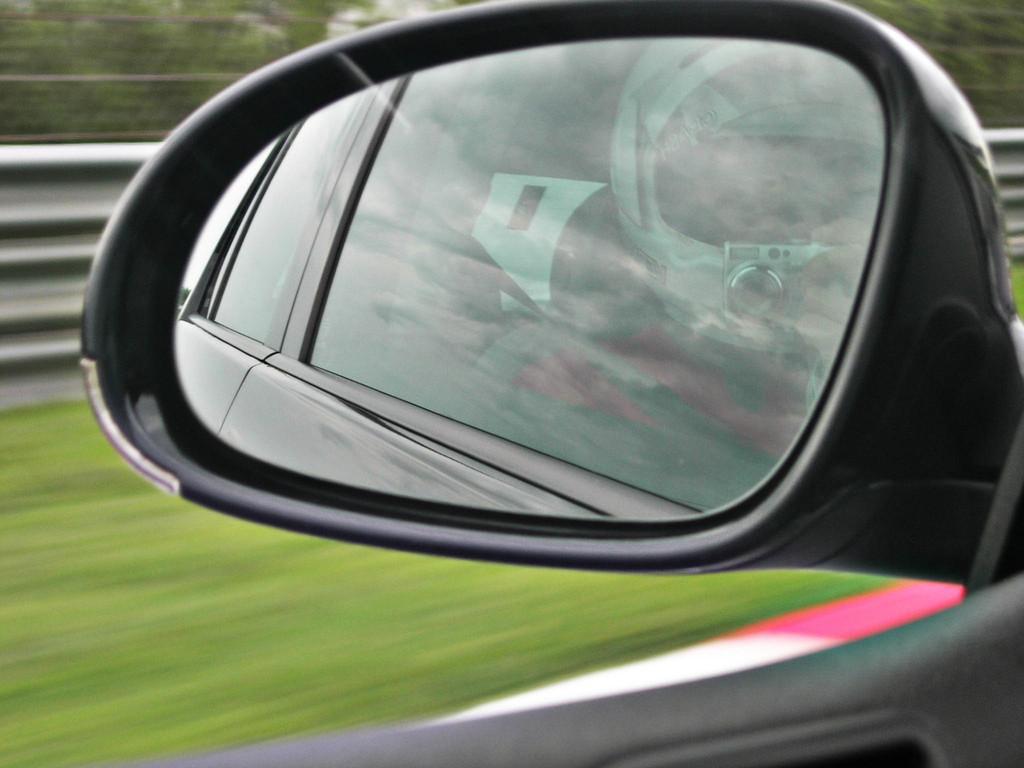In one or two sentences, can you explain what this image depicts? In this image there is a mirror of a car, where there is a reflection of a person with a helmet holding a camera, and in the background there is grass, iron sheet, trees. 